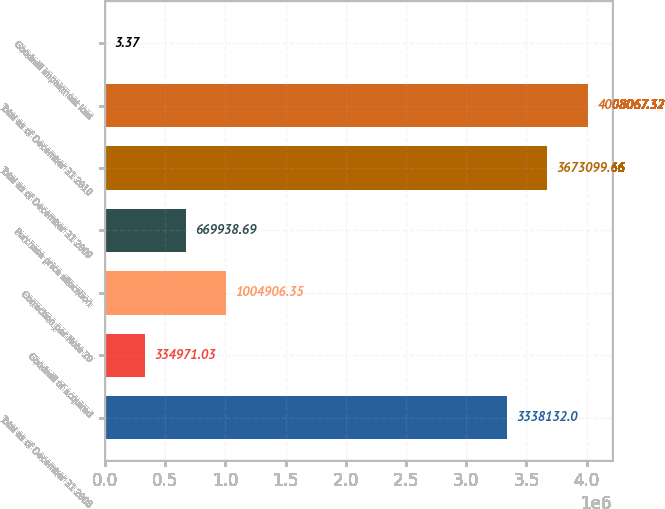<chart> <loc_0><loc_0><loc_500><loc_500><bar_chart><fcel>Total as of December 31 2008<fcel>Goodwill of acquired<fcel>Correction per Note 20<fcel>Purchase price allocation<fcel>Total as of December 31 2009<fcel>Total as of December 31 2010<fcel>Goodwill impairment loss<nl><fcel>3.33813e+06<fcel>334971<fcel>1.00491e+06<fcel>669939<fcel>3.6731e+06<fcel>4.00807e+06<fcel>3.37<nl></chart> 